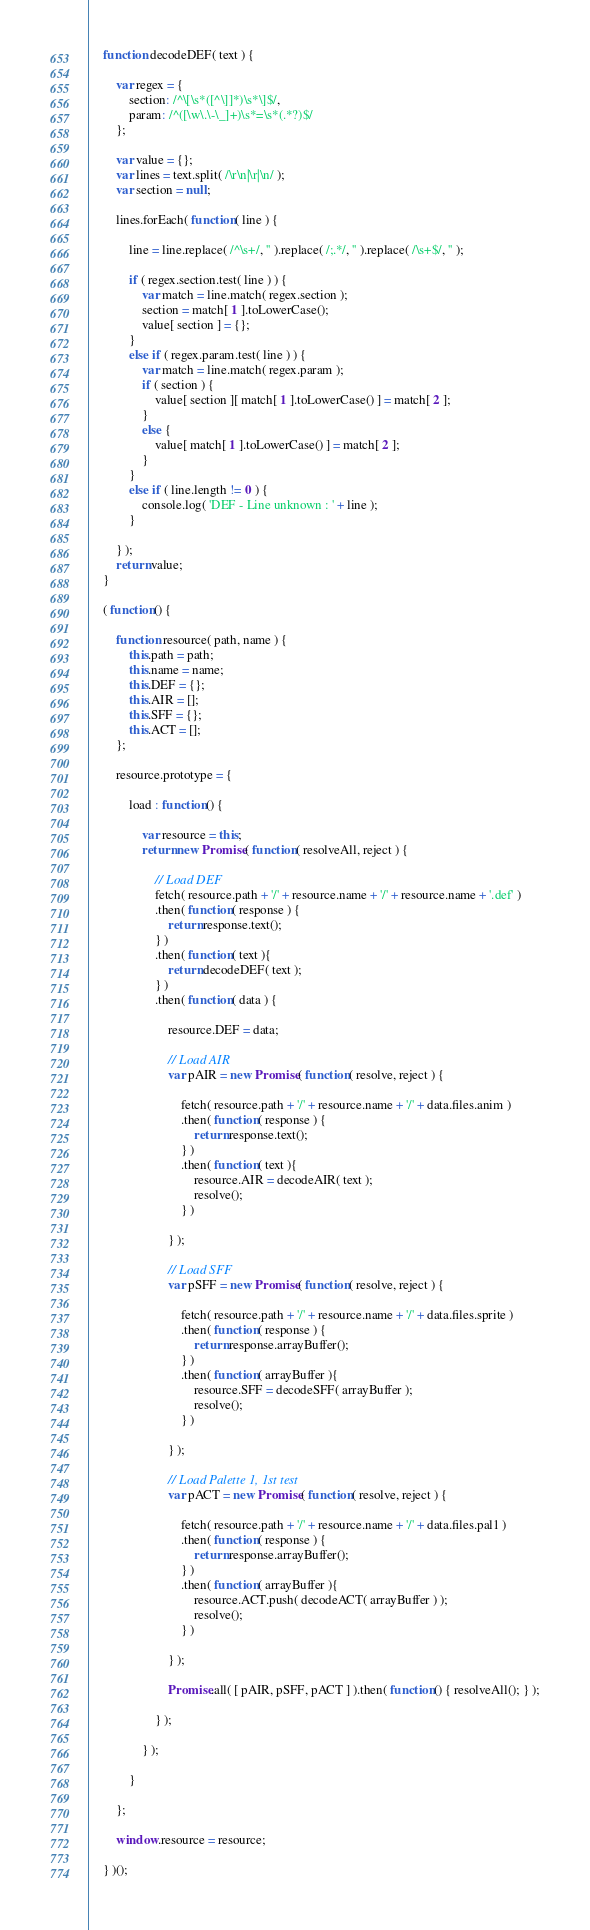<code> <loc_0><loc_0><loc_500><loc_500><_JavaScript_>	function decodeDEF( text ) {
	
		var regex = {
			section: /^\[\s*([^\]]*)\s*\]$/,
			param: /^([\w\.\-\_]+)\s*=\s*(.*?)$/
		};
		
		var value = {};
		var lines = text.split( /\r\n|\r|\n/ );
		var section = null;
		
		lines.forEach( function( line ) {
		
			line = line.replace( /^\s+/, '' ).replace( /;.*/, '' ).replace( /\s+$/, '' );
			
			if ( regex.section.test( line ) ) {
				var match = line.match( regex.section );
				section = match[ 1 ].toLowerCase();
				value[ section ] = {};
			}
			else if ( regex.param.test( line ) ) {
				var match = line.match( regex.param );
				if ( section ) {
					value[ section ][ match[ 1 ].toLowerCase() ] = match[ 2 ];
				}
				else {
					value[ match[ 1 ].toLowerCase() ] = match[ 2 ];
				} 
			}
			else if ( line.length != 0 ) { 	
				console.log( 'DEF - Line unknown : ' + line );
			}
			
		} );
		return value;
	}
	
	( function() {

		function resource( path, name ) {
			this.path = path;
			this.name = name;
			this.DEF = {};
			this.AIR = [];
			this.SFF = {};
			this.ACT = [];
		};
		
		resource.prototype = {
		
			load : function() {
			
				var resource = this;
				return new Promise( function( resolveAll, reject ) {
				
					// Load DEF
					fetch( resource.path + '/' + resource.name + '/' + resource.name + '.def' )
					.then( function( response ) { 
						return response.text();
					} )
					.then( function( text ){ 
						return decodeDEF( text ); 
					} )
					.then( function( data ) {
						
						resource.DEF = data;
						
						// Load AIR
						var pAIR = new Promise( function( resolve, reject ) { 
						
							fetch( resource.path + '/' + resource.name + '/' + data.files.anim )
							.then( function( response ) { 
								return response.text();
							} )
							.then( function( text ){ 
								resource.AIR = decodeAIR( text );
								resolve(); 
							} )
							
						} );
						
						// Load SFF
						var pSFF = new Promise( function( resolve, reject ) { 
						
							fetch( resource.path + '/' + resource.name + '/' + data.files.sprite )
							.then( function( response ) { 
								return response.arrayBuffer();
							} )
							.then( function( arrayBuffer ){ 
								resource.SFF = decodeSFF( arrayBuffer );
								resolve(); 
							} )
							
						} );
						
						// Load Palette 1, 1st test
						var pACT = new Promise( function( resolve, reject ) { 
						
							fetch( resource.path + '/' + resource.name + '/' + data.files.pal1 )
							.then( function( response ) { 
								return response.arrayBuffer();
							} )
							.then( function( arrayBuffer ){ 
								resource.ACT.push( decodeACT( arrayBuffer ) );
								resolve(); 
							} )
							
						} );
						
						Promise.all( [ pAIR, pSFF, pACT ] ).then( function() { resolveAll(); } );
						
					} );
					
				} );
				
			}
			
		};
		
		window.resource = resource;
			
	} )();</code> 